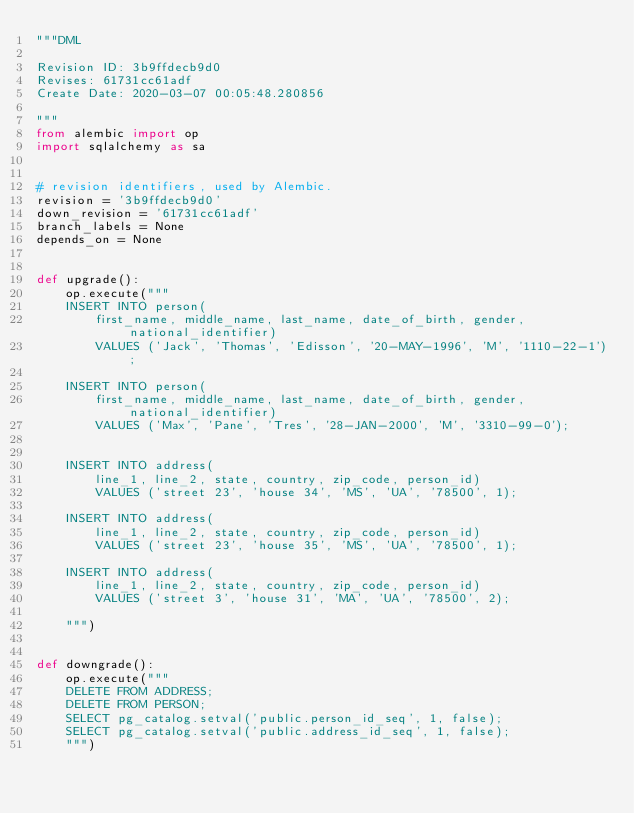<code> <loc_0><loc_0><loc_500><loc_500><_Python_>"""DML

Revision ID: 3b9ffdecb9d0
Revises: 61731cc61adf
Create Date: 2020-03-07 00:05:48.280856

"""
from alembic import op
import sqlalchemy as sa


# revision identifiers, used by Alembic.
revision = '3b9ffdecb9d0'
down_revision = '61731cc61adf'
branch_labels = None
depends_on = None


def upgrade():
    op.execute("""
    INSERT INTO person(
        first_name, middle_name, last_name, date_of_birth, gender, national_identifier)
        VALUES ('Jack', 'Thomas', 'Edisson', '20-MAY-1996', 'M', '1110-22-1');
        
    INSERT INTO person(
        first_name, middle_name, last_name, date_of_birth, gender, national_identifier)
        VALUES ('Max', 'Pane', 'Tres', '28-JAN-2000', 'M', '3310-99-0');
    
    
    INSERT INTO address(
        line_1, line_2, state, country, zip_code, person_id)
        VALUES ('street 23', 'house 34', 'MS', 'UA', '78500', 1);
    
    INSERT INTO address(
        line_1, line_2, state, country, zip_code, person_id)
        VALUES ('street 23', 'house 35', 'MS', 'UA', '78500', 1);
    
    INSERT INTO address(
        line_1, line_2, state, country, zip_code, person_id)
        VALUES ('street 3', 'house 31', 'MA', 'UA', '78500', 2);

    """)


def downgrade():
    op.execute("""
    DELETE FROM ADDRESS;
    DELETE FROM PERSON;
    SELECT pg_catalog.setval('public.person_id_seq', 1, false);
    SELECT pg_catalog.setval('public.address_id_seq', 1, false);
    """)</code> 